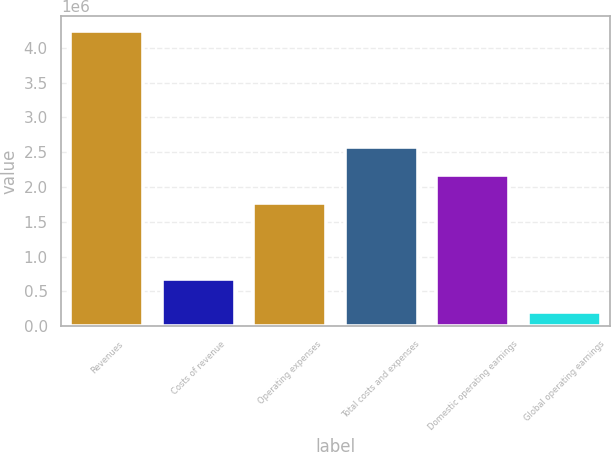<chart> <loc_0><loc_0><loc_500><loc_500><bar_chart><fcel>Revenues<fcel>Costs of revenue<fcel>Operating expenses<fcel>Total costs and expenses<fcel>Domestic operating earnings<fcel>Global operating earnings<nl><fcel>4.2451e+06<fcel>676437<fcel>1.77415e+06<fcel>2.58267e+06<fcel>2.17841e+06<fcel>202454<nl></chart> 